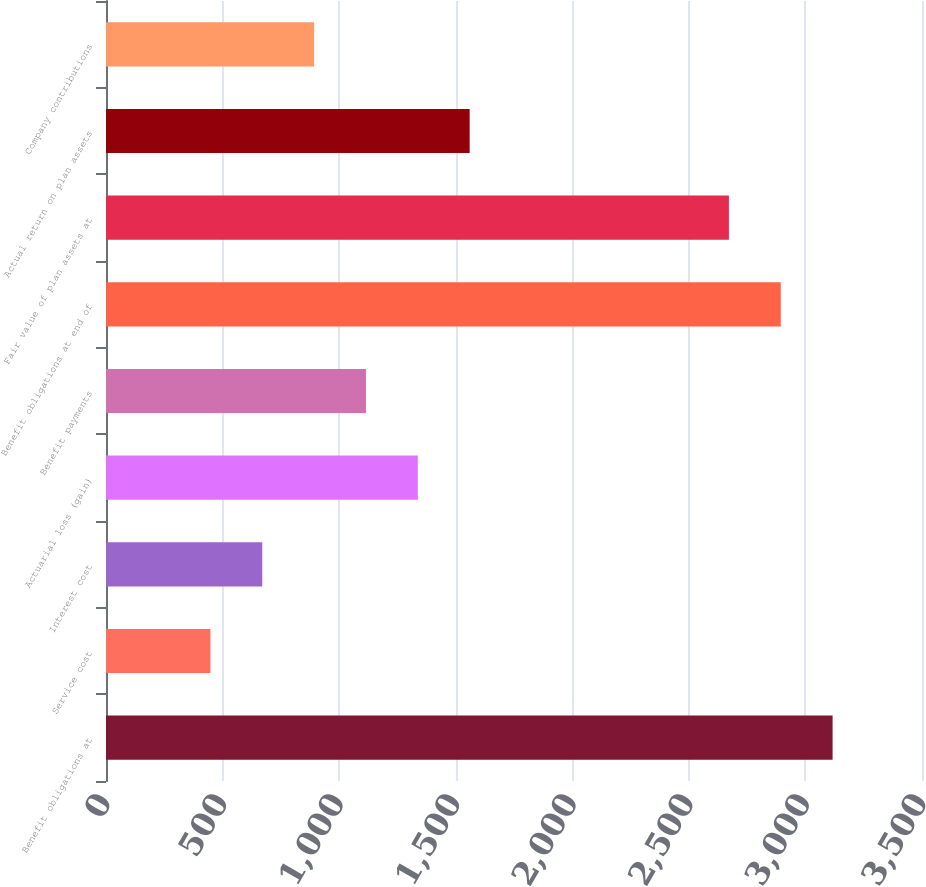Convert chart to OTSL. <chart><loc_0><loc_0><loc_500><loc_500><bar_chart><fcel>Benefit obligations at<fcel>Service cost<fcel>Interest cost<fcel>Actuarial loss (gain)<fcel>Benefit payments<fcel>Benefit obligations at end of<fcel>Fair value of plan assets at<fcel>Actual return on plan assets<fcel>Company contributions<nl><fcel>3116.6<fcel>447.8<fcel>670.2<fcel>1337.4<fcel>1115<fcel>2894.2<fcel>2671.8<fcel>1559.8<fcel>892.6<nl></chart> 